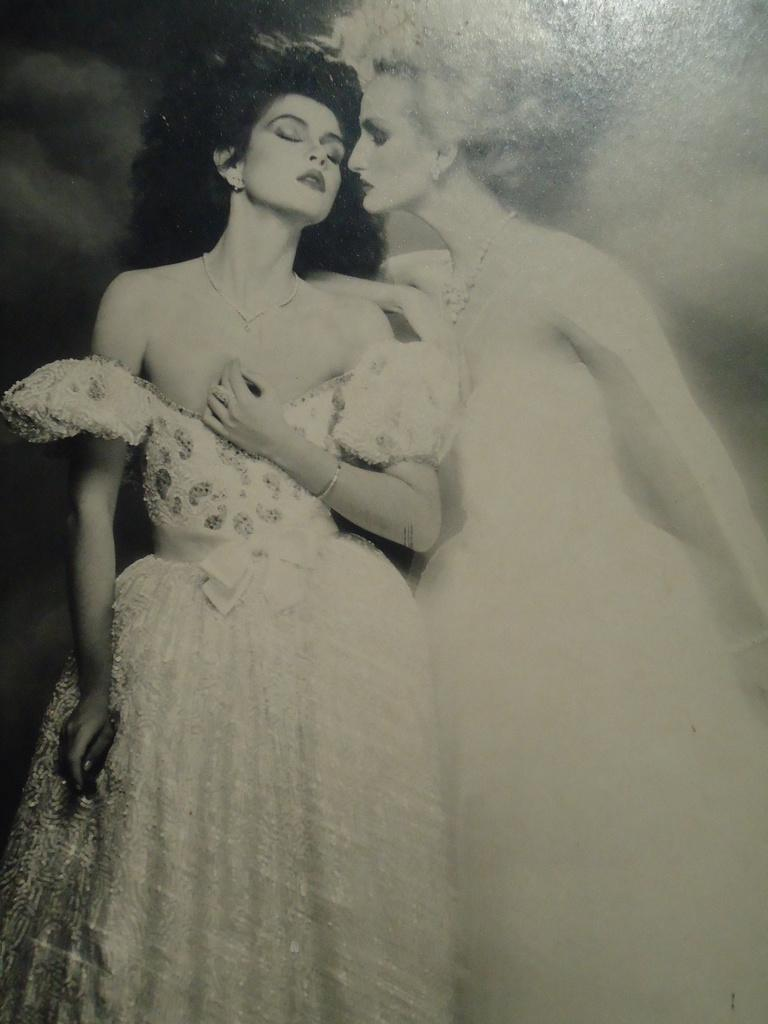What type of image is being described? The image is graphical in nature. How many people are present in the image? There are two persons in the image. What color scheme is used in the image? The image is black and white. How many babies are crawling on the floor in the image? There are no babies present in the image; it features two persons in a black and white, graphical setting. 